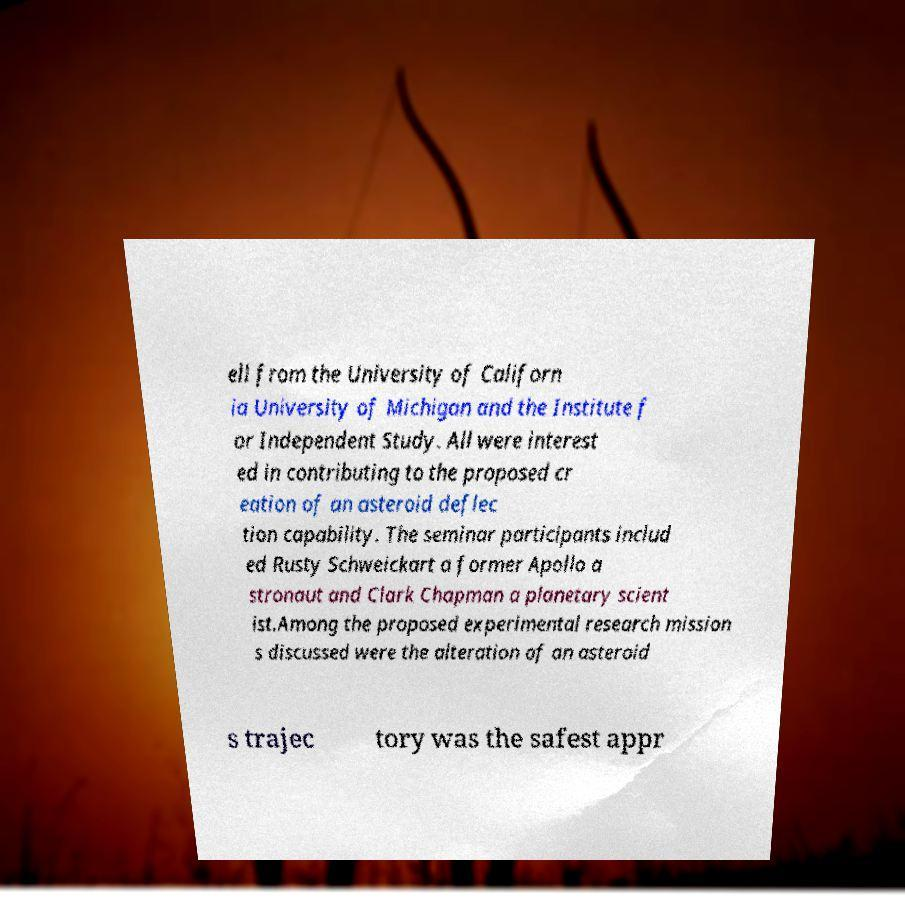Could you assist in decoding the text presented in this image and type it out clearly? ell from the University of Californ ia University of Michigan and the Institute f or Independent Study. All were interest ed in contributing to the proposed cr eation of an asteroid deflec tion capability. The seminar participants includ ed Rusty Schweickart a former Apollo a stronaut and Clark Chapman a planetary scient ist.Among the proposed experimental research mission s discussed were the alteration of an asteroid s trajec tory was the safest appr 